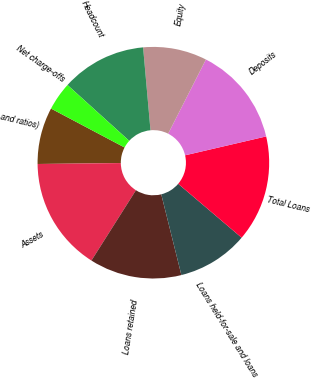<chart> <loc_0><loc_0><loc_500><loc_500><pie_chart><fcel>and ratios)<fcel>Assets<fcel>Loans retained<fcel>Loans held-for-sale and loans<fcel>Total Loans<fcel>Deposits<fcel>Equity<fcel>Headcount<fcel>Net charge-offs<nl><fcel>7.92%<fcel>15.84%<fcel>12.87%<fcel>9.9%<fcel>14.85%<fcel>13.86%<fcel>8.91%<fcel>11.88%<fcel>3.96%<nl></chart> 